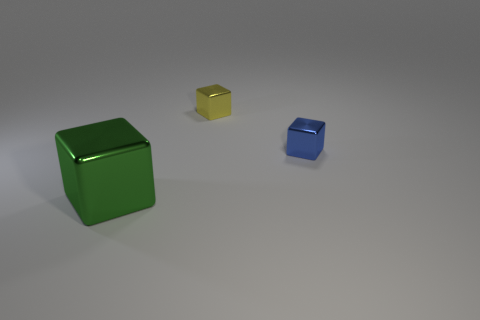Can you tell me what the texture of the cubes might feel like? While I cannot physically feel the texture, the cubes seem to have a smooth and possibly reflective surface, indicating they might feel sleek and cool to the touch. Do the cubes have any shadows or reflections on the surface they are on? Yes, each cube casts a shadow directly onto the surface, which helps provide a sense of their form and dimension. Additionally, there are subtle reflections visible beneath the cubes, hinting at a somewhat reflective ground surface. 